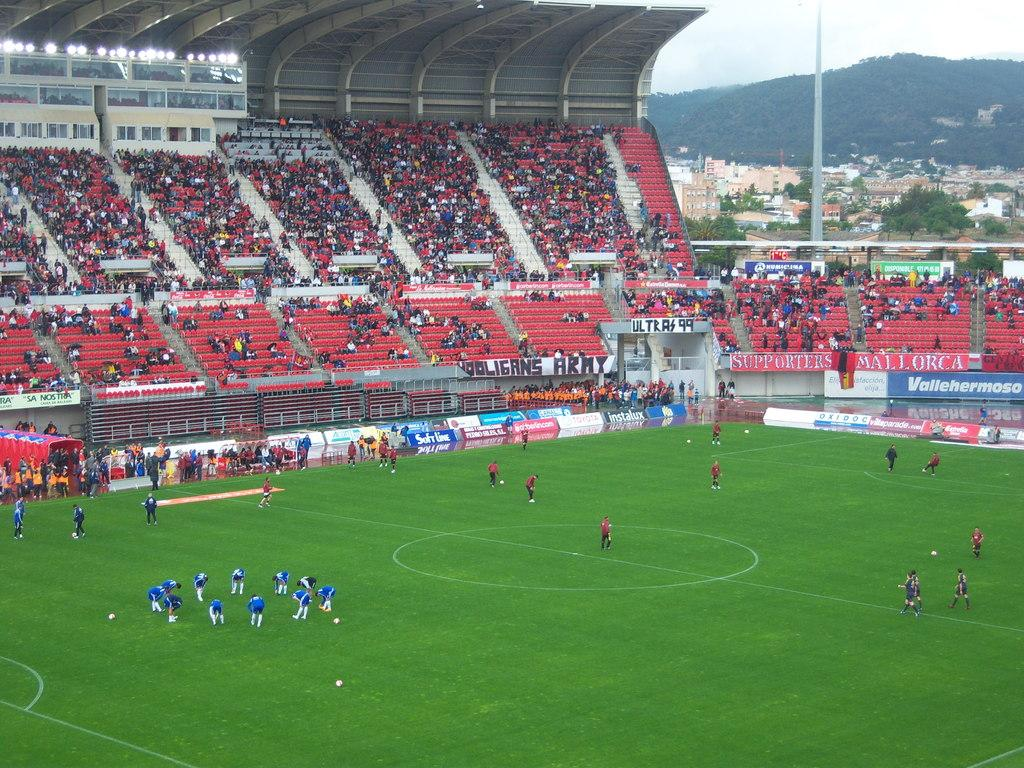What are the people on the green surface doing? The people are doing warm-up exercises. What type of event might be taking place based on the presence of an audience and a stadium? It could be a sports event or a performance, as there is an audience present and a stadium in the image. What can be seen in the background of the image? In the background, there is a pole, buildings, trees, and the sky. How many toes are visible on the people doing warm-up exercises? The number of toes visible on the people cannot be determined from the image, as it does not provide a close-up view of their feet. What type of lift is being used by the people in the image? There is no lift present in the image; the people are doing warm-up exercises on a green surface. 